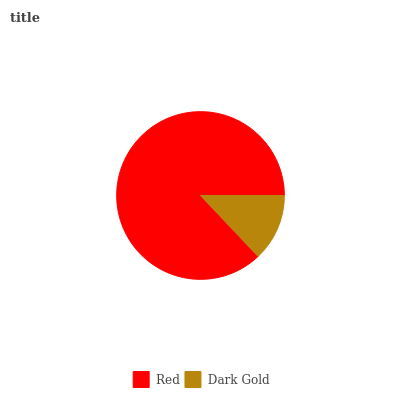Is Dark Gold the minimum?
Answer yes or no. Yes. Is Red the maximum?
Answer yes or no. Yes. Is Dark Gold the maximum?
Answer yes or no. No. Is Red greater than Dark Gold?
Answer yes or no. Yes. Is Dark Gold less than Red?
Answer yes or no. Yes. Is Dark Gold greater than Red?
Answer yes or no. No. Is Red less than Dark Gold?
Answer yes or no. No. Is Red the high median?
Answer yes or no. Yes. Is Dark Gold the low median?
Answer yes or no. Yes. Is Dark Gold the high median?
Answer yes or no. No. Is Red the low median?
Answer yes or no. No. 